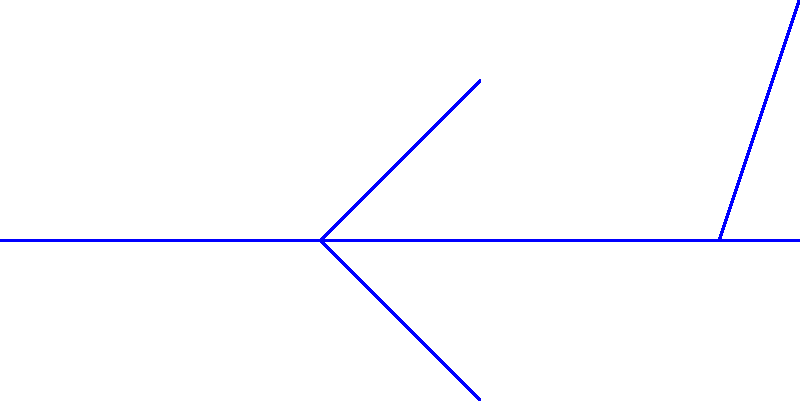Thunderbird 1's VTOL (Vertical Take-Off and Landing) engine is critical for its quick response capabilities. The engine rotor has a moment of inertia of $20 \text{ kg}\cdot\text{m}^2$. Two forces act on the rotor as shown in the diagram: $F_1 = 500 \text{ N}$ perpendicular to the radius at a distance of $0.2 \text{ m}$ from the axis of rotation, and $F_2 = 300 \text{ N}$ tangent to the rotor at a distance of $0.3 \text{ m}$ from the axis. Calculate the angular acceleration of the rotor in $\text{rad}/\text{s}^2$. To solve this problem, we'll follow these steps:

1) First, we need to calculate the torque ($\tau$) produced by each force:

   For $F_1$: $\tau_1 = F_1 \cdot r_1 = 500 \text{ N} \cdot 0.2 \text{ m} = 100 \text{ N}\cdot\text{m}$
   
   For $F_2$: $\tau_2 = F_2 \cdot r_2 = 300 \text{ N} \cdot 0.3 \text{ m} = 90 \text{ N}\cdot\text{m}$

2) The net torque is the sum of these individual torques:

   $\tau_{net} = \tau_1 + \tau_2 = 100 + 90 = 190 \text{ N}\cdot\text{m}$

3) We can use the rotational form of Newton's Second Law to relate torque to angular acceleration:

   $\tau_{net} = I\alpha$

   Where $I$ is the moment of inertia and $\alpha$ is the angular acceleration.

4) Rearranging this equation to solve for $\alpha$:

   $\alpha = \frac{\tau_{net}}{I} = \frac{190 \text{ N}\cdot\text{m}}{20 \text{ kg}\cdot\text{m}^2} = 9.5 \text{ rad}/\text{s}^2$

Therefore, the angular acceleration of the rotor is $9.5 \text{ rad}/\text{s}^2$.
Answer: $9.5 \text{ rad}/\text{s}^2$ 